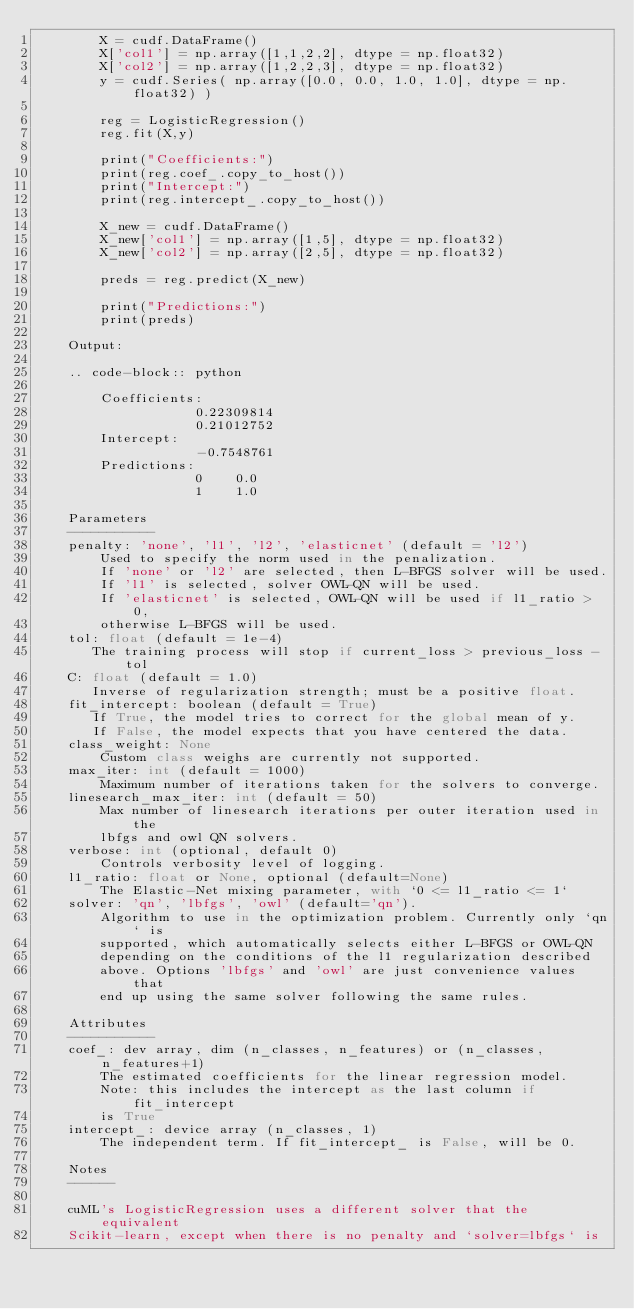<code> <loc_0><loc_0><loc_500><loc_500><_Cython_>        X = cudf.DataFrame()
        X['col1'] = np.array([1,1,2,2], dtype = np.float32)
        X['col2'] = np.array([1,2,2,3], dtype = np.float32)
        y = cudf.Series( np.array([0.0, 0.0, 1.0, 1.0], dtype = np.float32) )

        reg = LogisticRegression()
        reg.fit(X,y)

        print("Coefficients:")
        print(reg.coef_.copy_to_host())
        print("Intercept:")
        print(reg.intercept_.copy_to_host())

        X_new = cudf.DataFrame()
        X_new['col1'] = np.array([1,5], dtype = np.float32)
        X_new['col2'] = np.array([2,5], dtype = np.float32)

        preds = reg.predict(X_new)

        print("Predictions:")
        print(preds)

    Output:

    .. code-block:: python

        Coefficients:
                    0.22309814
                    0.21012752
        Intercept:
                    -0.7548761
        Predictions:
                    0    0.0
                    1    1.0

    Parameters
    -----------
    penalty: 'none', 'l1', 'l2', 'elasticnet' (default = 'l2')
        Used to specify the norm used in the penalization.
        If 'none' or 'l2' are selected, then L-BFGS solver will be used.
        If 'l1' is selected, solver OWL-QN will be used.
        If 'elasticnet' is selected, OWL-QN will be used if l1_ratio > 0,
        otherwise L-BFGS will be used.
    tol: float (default = 1e-4)
       The training process will stop if current_loss > previous_loss - tol
    C: float (default = 1.0)
       Inverse of regularization strength; must be a positive float.
    fit_intercept: boolean (default = True)
       If True, the model tries to correct for the global mean of y.
       If False, the model expects that you have centered the data.
    class_weight: None
        Custom class weighs are currently not supported.
    max_iter: int (default = 1000)
        Maximum number of iterations taken for the solvers to converge.
    linesearch_max_iter: int (default = 50)
        Max number of linesearch iterations per outer iteration used in the
        lbfgs and owl QN solvers.
    verbose: int (optional, default 0)
        Controls verbosity level of logging.
    l1_ratio: float or None, optional (default=None)
        The Elastic-Net mixing parameter, with `0 <= l1_ratio <= 1`
    solver: 'qn', 'lbfgs', 'owl' (default='qn').
        Algorithm to use in the optimization problem. Currently only `qn` is
        supported, which automatically selects either L-BFGS or OWL-QN
        depending on the conditions of the l1 regularization described
        above. Options 'lbfgs' and 'owl' are just convenience values that
        end up using the same solver following the same rules.

    Attributes
    -----------
    coef_: dev array, dim (n_classes, n_features) or (n_classes, n_features+1)
        The estimated coefficients for the linear regression model.
        Note: this includes the intercept as the last column if fit_intercept
        is True
    intercept_: device array (n_classes, 1)
        The independent term. If fit_intercept_ is False, will be 0.

    Notes
    ------

    cuML's LogisticRegression uses a different solver that the equivalent
    Scikit-learn, except when there is no penalty and `solver=lbfgs` is</code> 